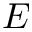Convert formula to latex. <formula><loc_0><loc_0><loc_500><loc_500>E</formula> 